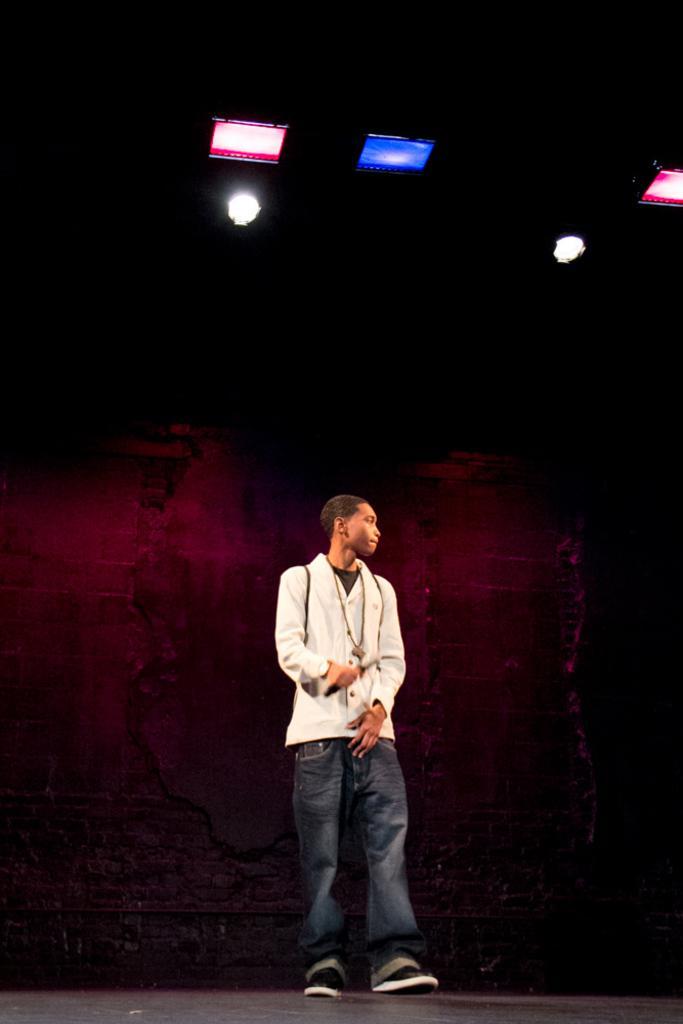Describe this image in one or two sentences. In this image in the center there is one person who is standing, and in the background there is wall. At the top there are some lights, and at the bottom there is floor. 